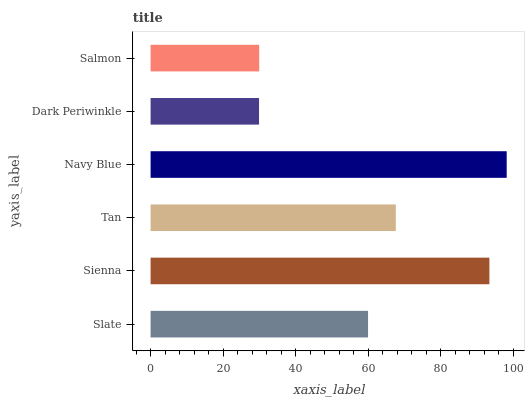Is Dark Periwinkle the minimum?
Answer yes or no. Yes. Is Navy Blue the maximum?
Answer yes or no. Yes. Is Sienna the minimum?
Answer yes or no. No. Is Sienna the maximum?
Answer yes or no. No. Is Sienna greater than Slate?
Answer yes or no. Yes. Is Slate less than Sienna?
Answer yes or no. Yes. Is Slate greater than Sienna?
Answer yes or no. No. Is Sienna less than Slate?
Answer yes or no. No. Is Tan the high median?
Answer yes or no. Yes. Is Slate the low median?
Answer yes or no. Yes. Is Slate the high median?
Answer yes or no. No. Is Salmon the low median?
Answer yes or no. No. 